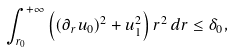<formula> <loc_0><loc_0><loc_500><loc_500>\int _ { r _ { 0 } } ^ { + \infty } \left ( ( \partial _ { r } u _ { 0 } ) ^ { 2 } + u _ { 1 } ^ { 2 } \right ) r ^ { 2 } \, d r \leq \delta _ { 0 } ,</formula> 